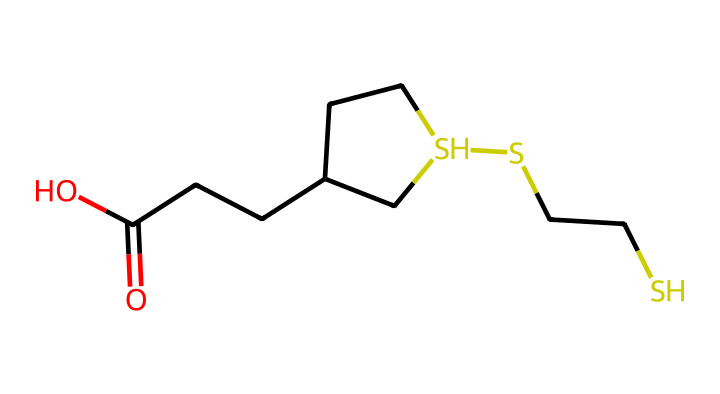What is the primary functional group present in lipoic acid? The structure shows a carboxylic acid group (–COOH) indicated by the carbon atom double-bonded to oxygen and single-bonded to a hydroxyl group.
Answer: carboxylic acid How many sulfur atoms are there in lipoic acid? In the SMILES representation, there are two sulfur atoms (S) indicated in the structure, confirming their presence within the molecular formula.
Answer: two What is the total number of carbon atoms in lipoic acid? By counting the carbon (C) atoms in the structure provided in the SMILES notation, there are eight carbon atoms.
Answer: eight Does lipoic acid contain any double bonds? The SMILES notation shows a carbonyl (C=O) functional group, which is a double bond between the carbon and oxygen, confirming the presence of a double bond.
Answer: yes What is the role of the sulfur atoms in lipoic acid? The sulfur atoms in lipoic acid play a crucial role in redox reactions, which helps in the antioxidant properties of the compound by stabilizing free radicals.
Answer: antioxidant How many rings are present in the structural formula of lipoic acid? Analyzing the structural formula, there is one ring indicated in the depiction of the cyclic part of the molecule, confirming the presence of a cyclic structure.
Answer: one 